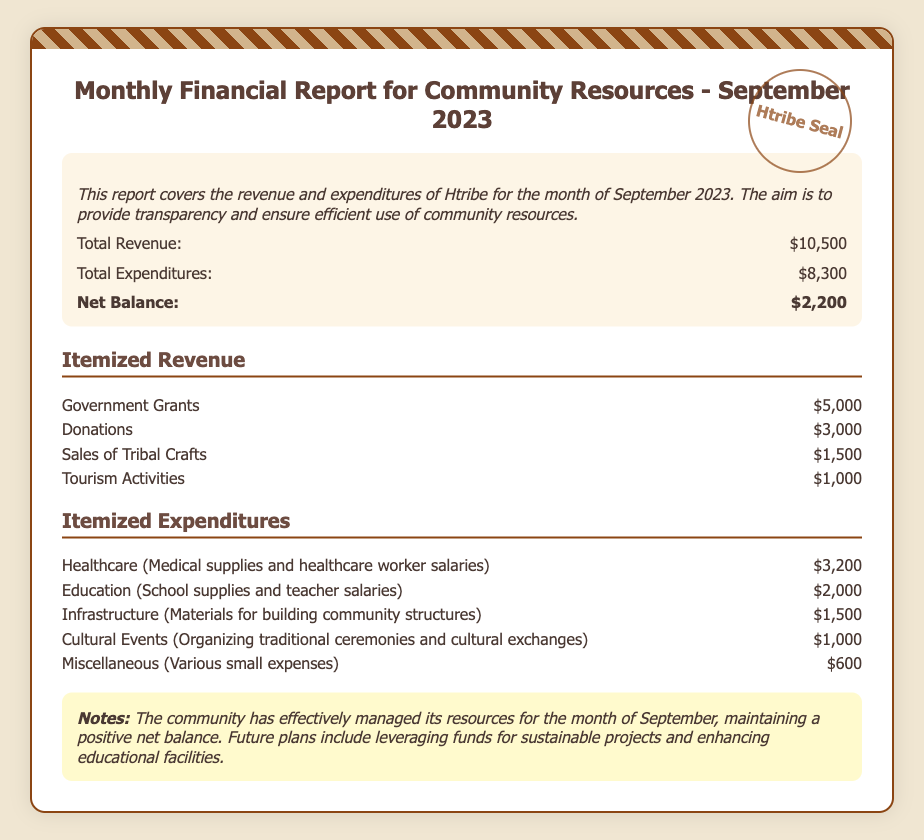what is the total revenue? The total revenue is stated at the bottom of the overview section, which sums up the revenue from different sources.
Answer: $10,500 what is the net balance? The net balance is calculated by subtracting total expenditures from total revenue, as indicated in the overview section.
Answer: $2,200 how much was spent on healthcare? The expenditure for healthcare is listed in the itemized expenditures section.
Answer: $3,200 what was the revenue from sales of tribal crafts? The revenue from sales of tribal crafts is detailed in the itemized revenue section.
Answer: $1,500 which category had the highest expenditure? The highest expenditure can be identified by comparing the amounts listed in the itemized expenditures section.
Answer: Healthcare what is the total amount spent on education? The total amount spent on education can be found in the itemized expenditures section for education.
Answer: $2,000 how much revenue was generated from tourism activities? The revenue from tourism activities is mentioned in the itemized revenue section.
Answer: $1,000 what percentage of total revenue comes from donations? To find the percentage, one would divide donations by total revenue and multiply by 100, as shown in the itemized revenue section.
Answer: 28.57% what is the purpose of the notes section? The notes section provides additional context and future plans regarding resource management, as stated in the document.
Answer: Context and future plans 